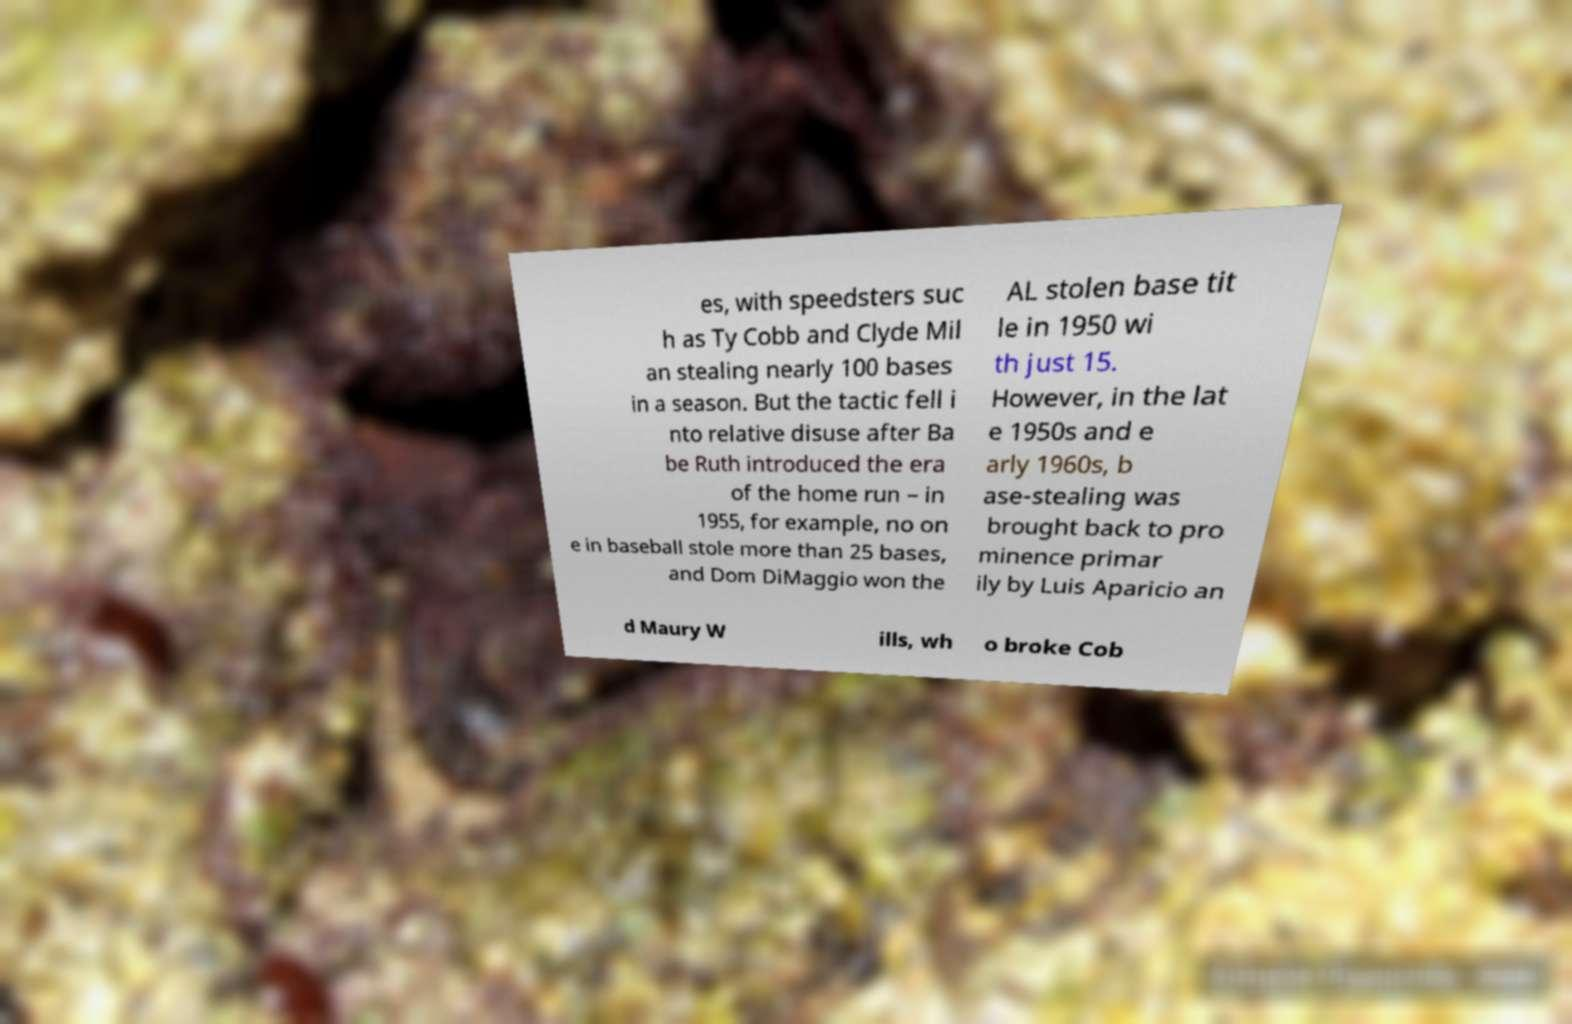There's text embedded in this image that I need extracted. Can you transcribe it verbatim? es, with speedsters suc h as Ty Cobb and Clyde Mil an stealing nearly 100 bases in a season. But the tactic fell i nto relative disuse after Ba be Ruth introduced the era of the home run – in 1955, for example, no on e in baseball stole more than 25 bases, and Dom DiMaggio won the AL stolen base tit le in 1950 wi th just 15. However, in the lat e 1950s and e arly 1960s, b ase-stealing was brought back to pro minence primar ily by Luis Aparicio an d Maury W ills, wh o broke Cob 